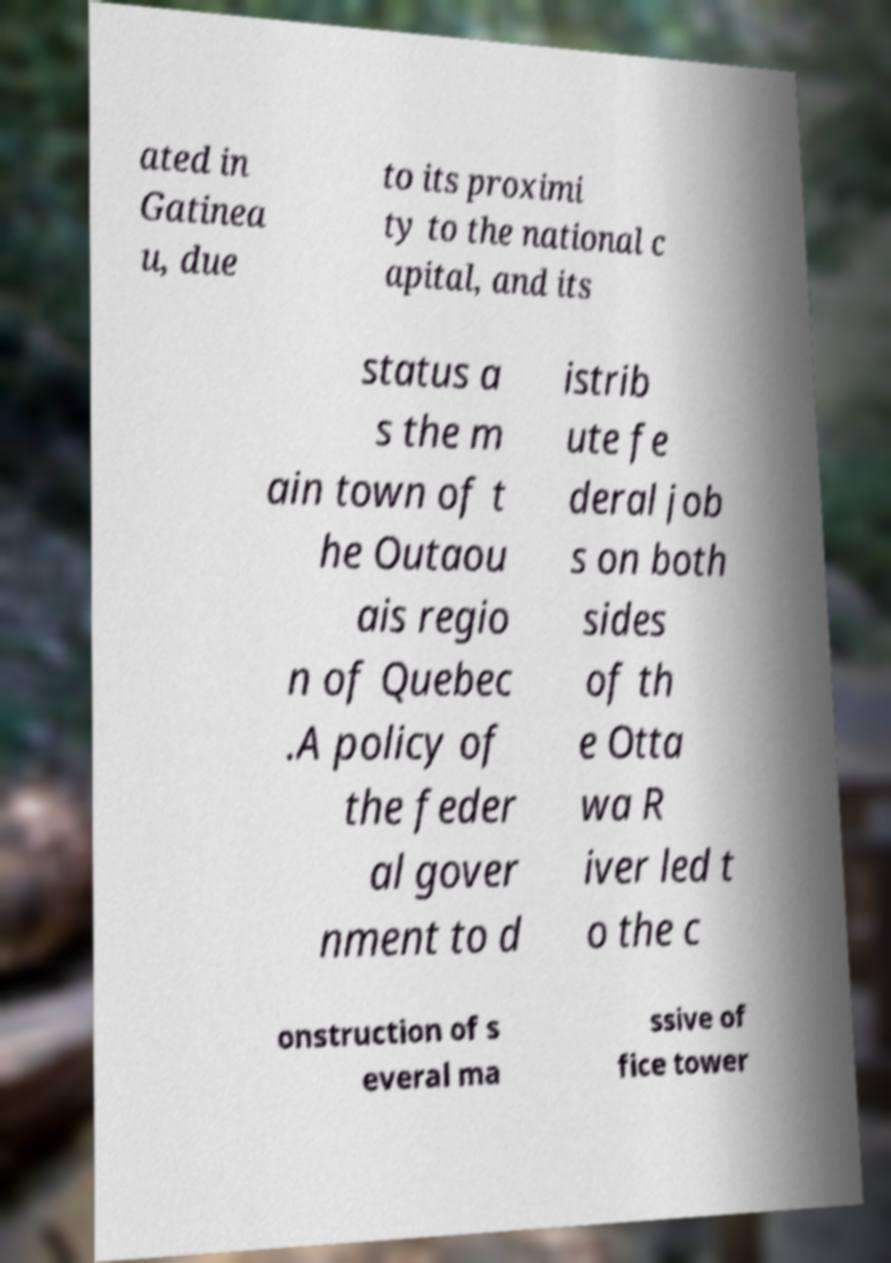Can you read and provide the text displayed in the image?This photo seems to have some interesting text. Can you extract and type it out for me? ated in Gatinea u, due to its proximi ty to the national c apital, and its status a s the m ain town of t he Outaou ais regio n of Quebec .A policy of the feder al gover nment to d istrib ute fe deral job s on both sides of th e Otta wa R iver led t o the c onstruction of s everal ma ssive of fice tower 